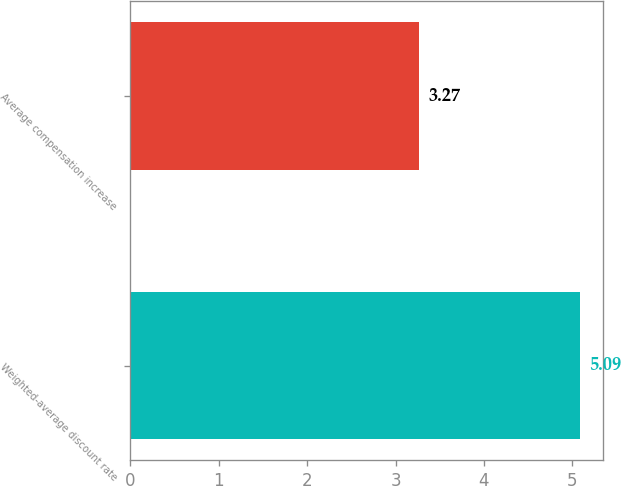Convert chart to OTSL. <chart><loc_0><loc_0><loc_500><loc_500><bar_chart><fcel>Weighted-average discount rate<fcel>Average compensation increase<nl><fcel>5.09<fcel>3.27<nl></chart> 